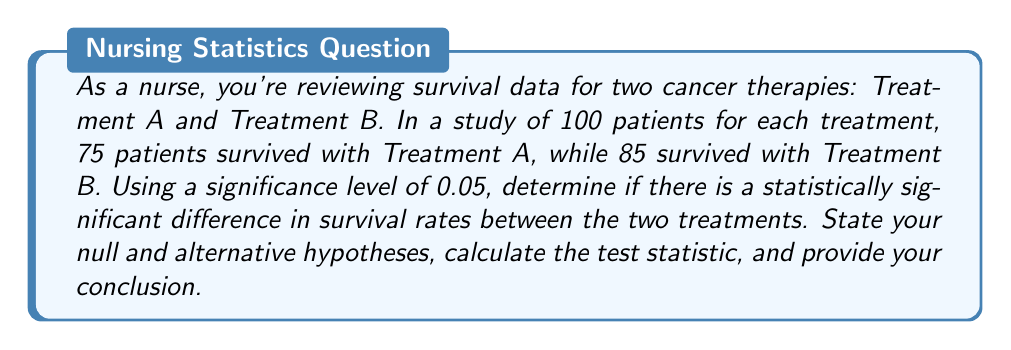Teach me how to tackle this problem. 1. State the hypotheses:
   Null hypothesis ($H_0$): $p_A = p_B$ (no difference in survival rates)
   Alternative hypothesis ($H_a$): $p_A \neq p_B$ (there is a difference in survival rates)

2. Calculate the pooled proportion:
   $\hat{p} = \frac{X_A + X_B}{n_A + n_B} = \frac{75 + 85}{100 + 100} = \frac{160}{200} = 0.8$

3. Calculate the standard error:
   $SE = \sqrt{\hat{p}(1-\hat{p})(\frac{1}{n_A} + \frac{1}{n_B})}$
   $SE = \sqrt{0.8(1-0.8)(\frac{1}{100} + \frac{1}{100})} = \sqrt{0.16 \cdot 0.02} = 0.0566$

4. Calculate the test statistic (z-score):
   $z = \frac{(\hat{p}_A - \hat{p}_B) - 0}{SE} = \frac{(0.75 - 0.85) - 0}{0.0566} = -1.77$

5. Find the critical values:
   For a two-tailed test with α = 0.05, the critical values are ±1.96.

6. Compare the test statistic to the critical values:
   |-1.77| < 1.96, so we fail to reject the null hypothesis.

7. Conclusion:
   At a 0.05 significance level, there is not enough evidence to conclude that there is a statistically significant difference in survival rates between Treatment A and Treatment B.
Answer: Fail to reject the null hypothesis; no significant difference in survival rates (p > 0.05) 